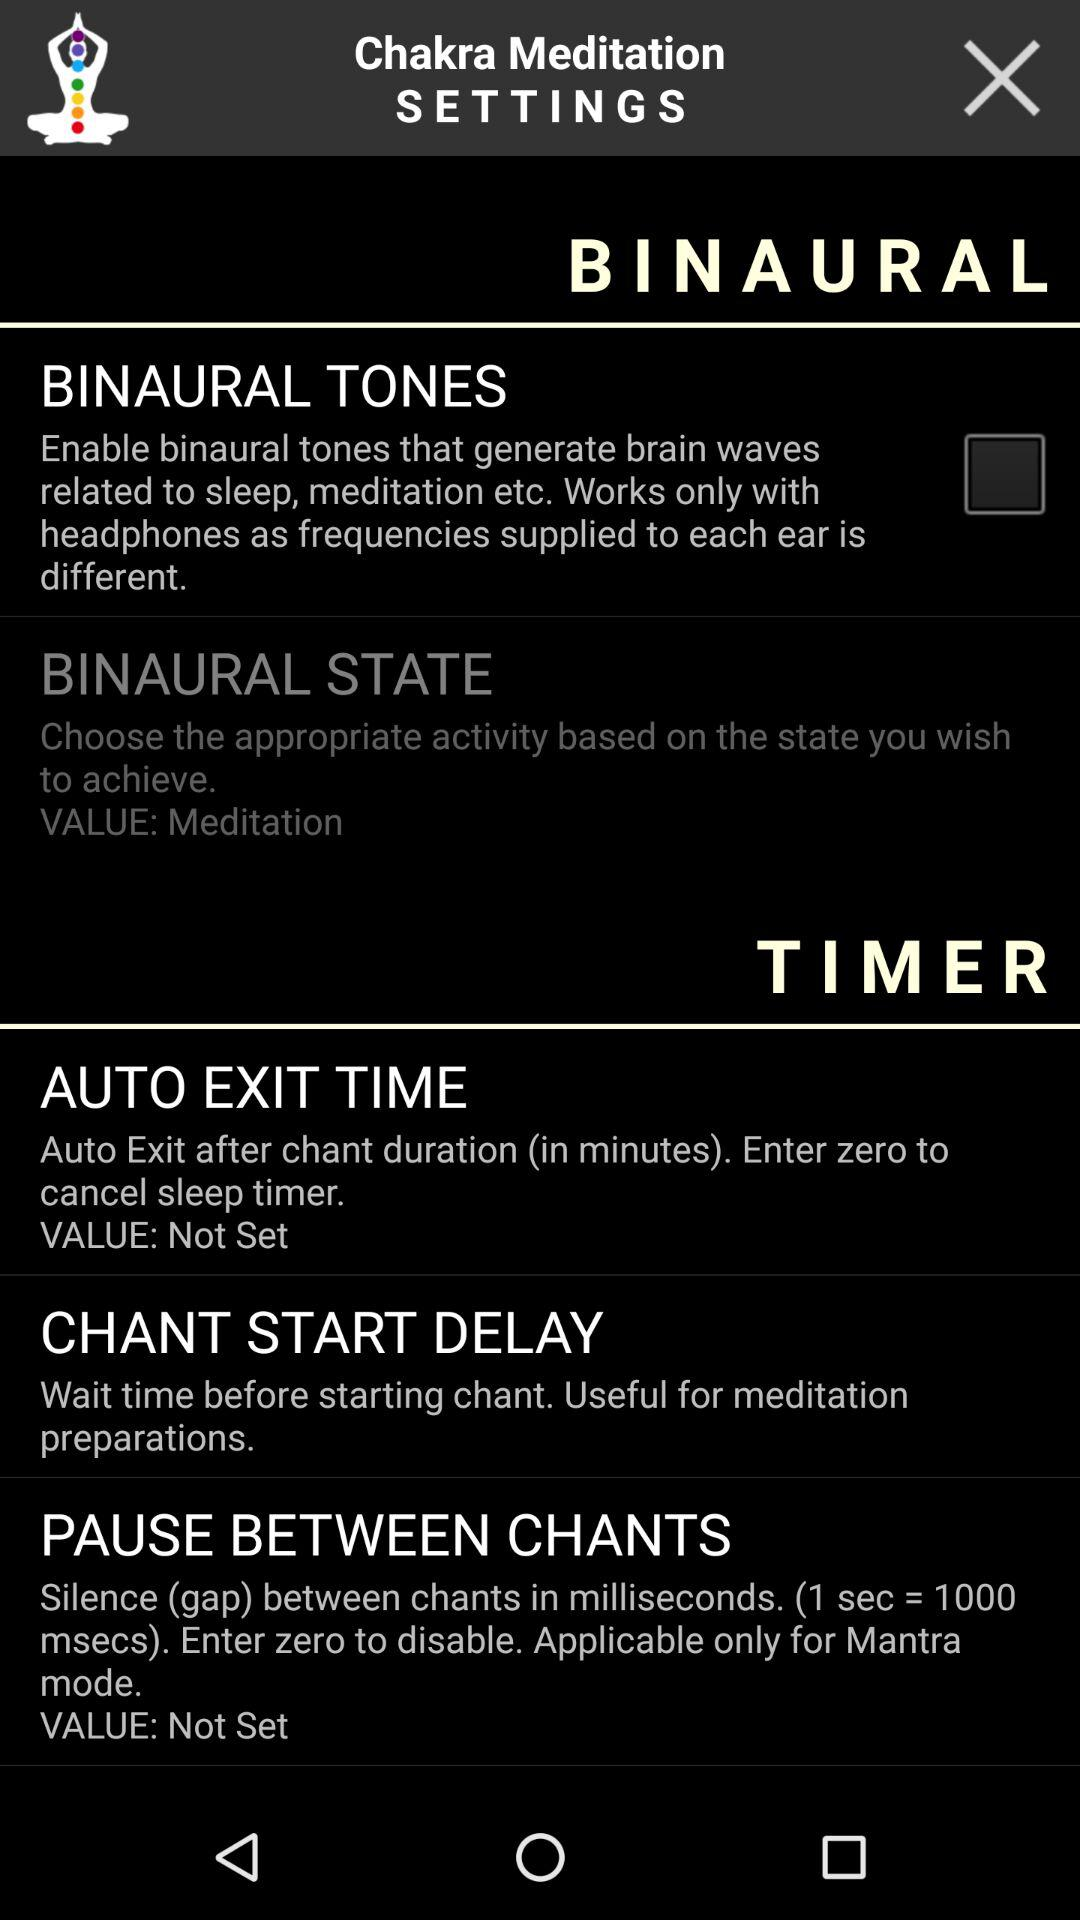What is the value chosen for "Binaural state"? The value is meditation. 